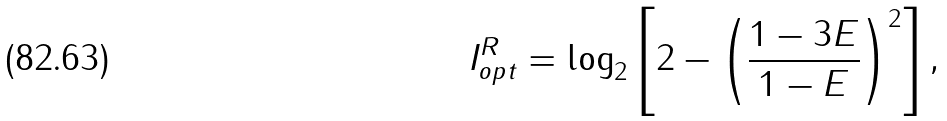<formula> <loc_0><loc_0><loc_500><loc_500>I _ { o p t } ^ { R } = \log _ { 2 } \left [ 2 - \left ( \frac { 1 - 3 E } { 1 - E } \right ) ^ { 2 } \right ] ,</formula> 